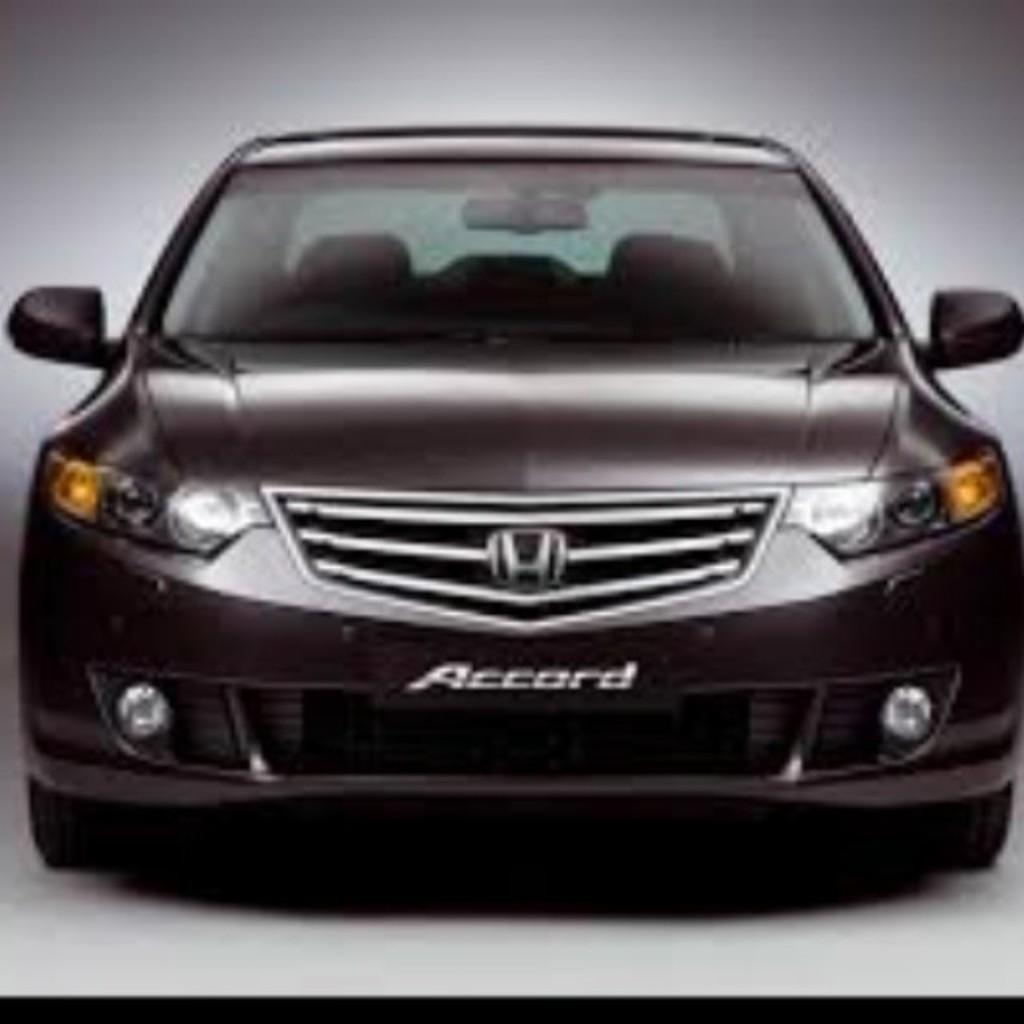What is the main subject of the image? The main subject of the image is a car. Can you describe any specific features of the car? Yes, the car has some text on it. What is the chance of finding a lock on the car in the image? There is no information about a lock on the car in the image, so it cannot be determined from the image. 